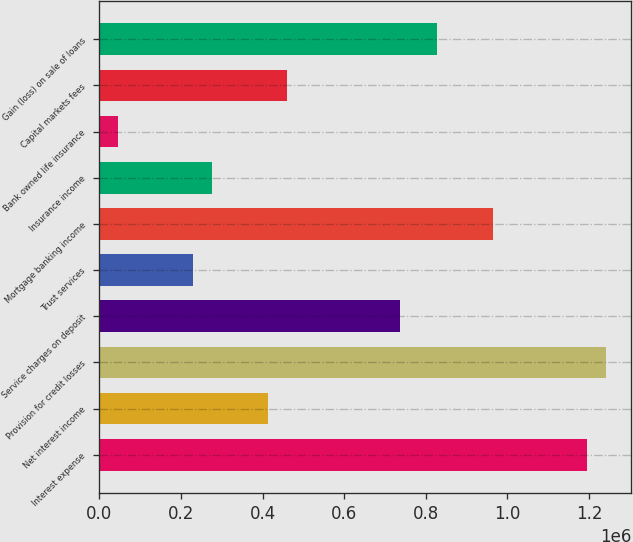Convert chart. <chart><loc_0><loc_0><loc_500><loc_500><bar_chart><fcel>Interest expense<fcel>Net interest income<fcel>Provision for credit losses<fcel>Service charges on deposit<fcel>Trust services<fcel>Mortgage banking income<fcel>Insurance income<fcel>Bank owned life insurance<fcel>Capital markets fees<fcel>Gain (loss) on sale of loans<nl><fcel>1.19524e+06<fcel>414566<fcel>1.24116e+06<fcel>736021<fcel>230878<fcel>965631<fcel>276800<fcel>47189.1<fcel>460488<fcel>827865<nl></chart> 